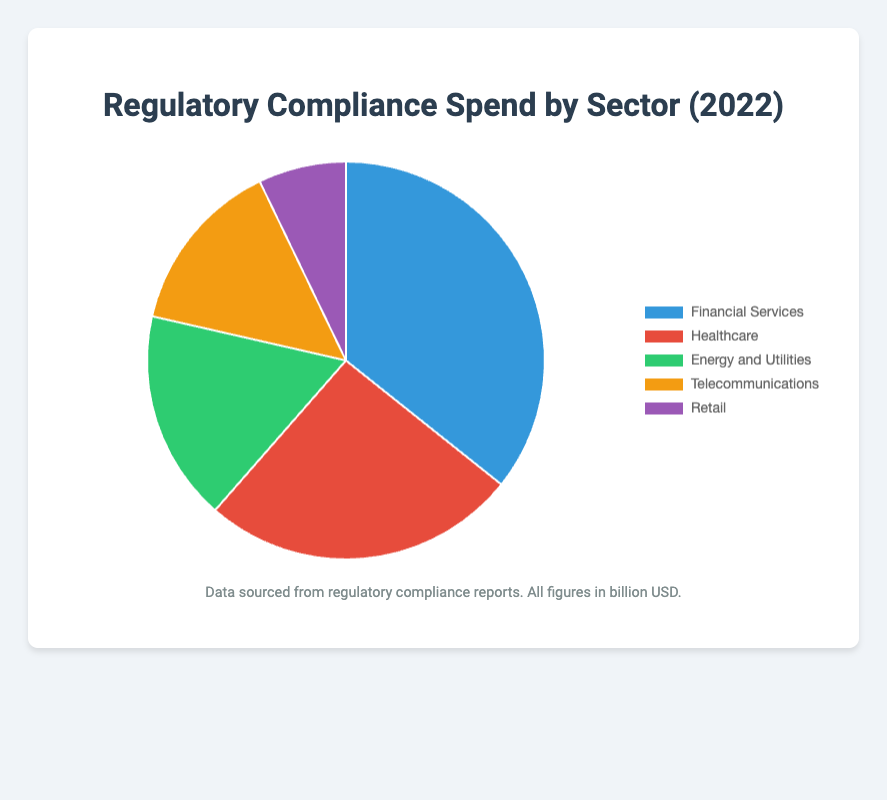What's the total regulatory compliance spend across all sectors in 2022? To find the total compliance spend, sum the spends across all sectors: 25 (Financial Services) + 18 (Healthcare) + 12 (Energy and Utilities) + 10 (Telecommunications) + 5 (Retail). The sum is 70.
Answer: 70 billion USD Which sector has the highest regulatory compliance spend in 2022? From the pie chart, the Financial Services sector has the largest segment, indicating the highest spend of 25 billion USD.
Answer: Financial Services How much more did the Financial Services sector spend on compliance compared to the Retail sector? The spend for Financial Services is 25 billion USD, and for Retail, it is 5 billion USD. The difference is 25 - 5 = 20 billion USD.
Answer: 20 billion USD What percentage of the total compliance spend does the Healthcare sector account for? The total spend is 70 billion USD. The Healthcare sector spends 18 billion USD. Percentage is calculated as (18 / 70) * 100 = 25.71%.
Answer: 25.71% How does the compliance spend in the Telecommunications sector compare to that in the Energy and Utilities sector? The spend for Telecommunications is 10 billion USD and for Energy and Utilities is 12 billion USD. Therefore, Telecommunications spends 2 billion USD less.
Answer: 2 billion USD less Which sector has the least regulatory compliance spend and how much is it? The Retail sector has the smallest segment in the pie chart, indicating the least spend of 5 billion USD.
Answer: Retail, 5 billion USD What's the combined compliance spend of the Energy and Utilities and Telecommunications sectors in 2022? To find the combined spend, add the spends for Energy and Utilities (12 billion USD) and Telecommunications (10 billion USD). The total is 12 + 10 = 22 billion USD.
Answer: 22 billion USD What is the ratio of compliance spend between Healthcare and Telecommunications sectors? The Healthcare sector spend is 18 billion USD, and the Telecommunications spend is 10 billion USD. The ratio is 18:10, which simplifies to 9:5.
Answer: 9:5 If the compliance spend for Retail were doubled, what would be the new total compliance spend across all sectors? The current total is 70 billion USD. Doubling Retail's spend from 5 billion USD to 10 billion USD would add an extra 5 billion USD to the total, making it 70 + 5 = 75 billion USD.
Answer: 75 billion USD 